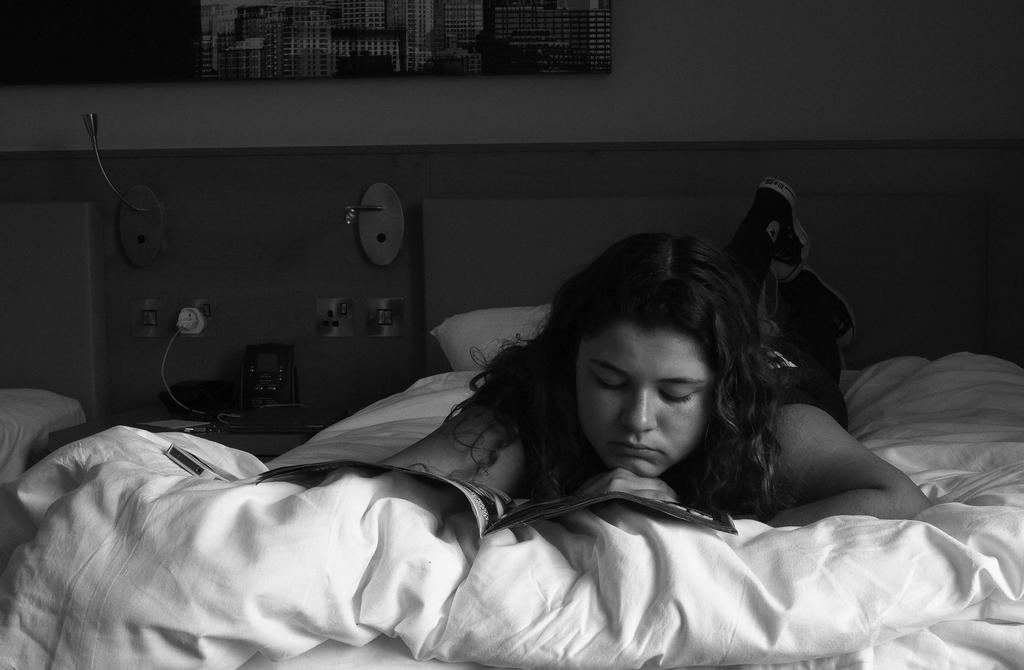Who is the main subject in the image? There is a lady person in the image. What is the lady person doing in the image? The lady person is lying on the bed and reading a book. Can you describe the background of the image? There is a charger socket slot in the background of the image. What type of cloth is being used to cover the territory in the image? There is no cloth or territory present in the image. What shape is the lady person in the image? The lady person is not depicted as a specific shape in the image; she is shown as a person lying on a bed. 